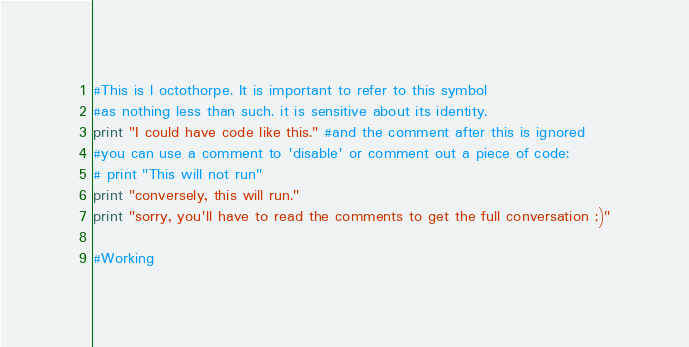<code> <loc_0><loc_0><loc_500><loc_500><_Python_>#This is l octothorpe. It is important to refer to this symbol
#as nothing less than such. it is sensitive about its identity.
print "I could have code like this." #and the comment after this is ignored
#you can use a comment to 'disable' or comment out a piece of code:
# print "This will not run"
print "conversely, this will run."
print "sorry, you'll have to read the comments to get the full conversation ;)"

#Working
</code> 